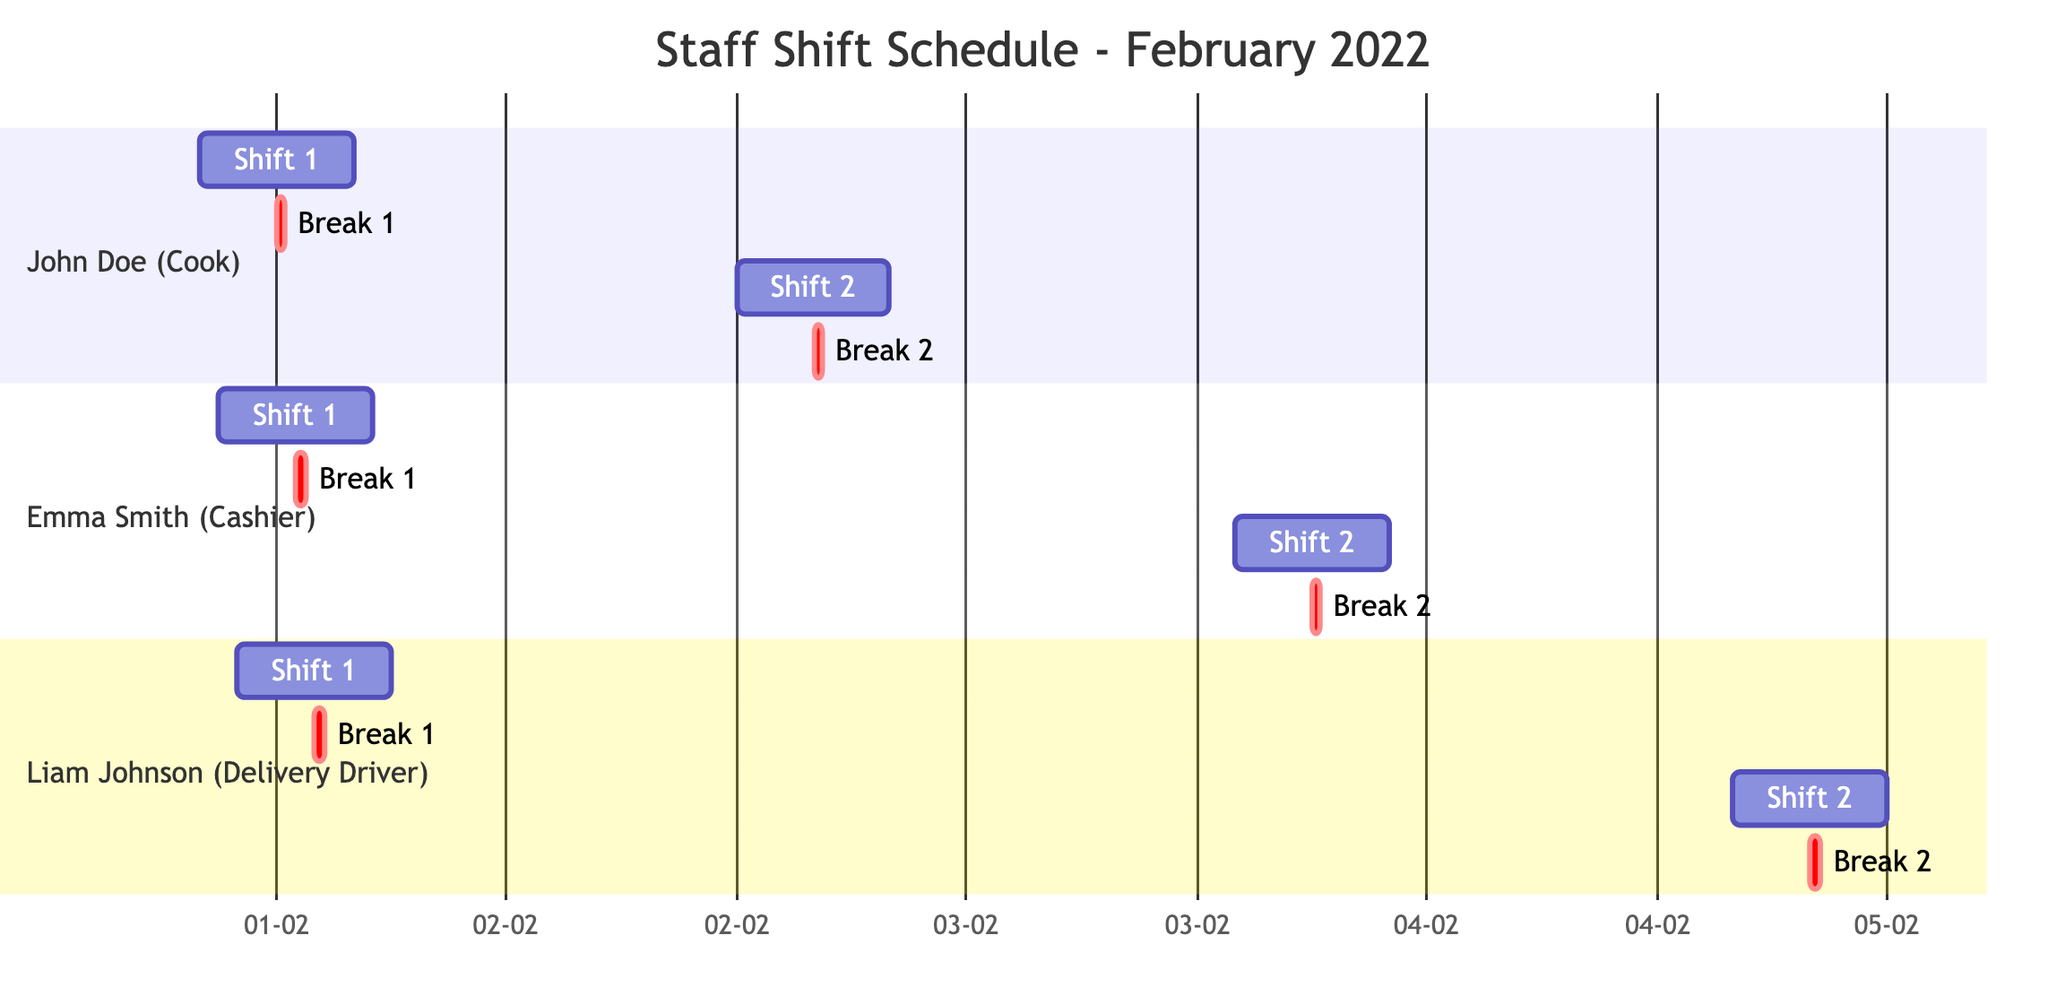What are the start times of John Doe's shifts? John Doe has two shifts in February 2022. The first shift starts at 08:00 on February 1st, and the second shift starts at 12:00 on February 2nd.
Answer: 08:00, 12:00 How many breaks does Emma Smith have in February 2022? Emma Smith has two breaks scheduled: one on February 1st at 13:00 and another on February 3rd at 18:00. Therefore, she has a total of two breaks.
Answer: 2 What is the duration of Liam Johnson's shift on February 4th? Liam Johnson's shift on February 4th is scheduled for 8 hours, as indicated in the diagram.
Answer: 8h Which employee has a lunch break scheduled first in February 2022? By examining the breaks, John Doe's first break is at 12:00 on February 1st, which is earlier than Emma Smith's and Liam Johnson's breaks. Therefore, John Doe has the first lunch break.
Answer: John Doe What is the total number of shifts shown in the diagram? The diagram outlines a total of six shifts: two for John Doe, two for Emma Smith, and two for Liam Johnson, totaling to six shifts.
Answer: 6 